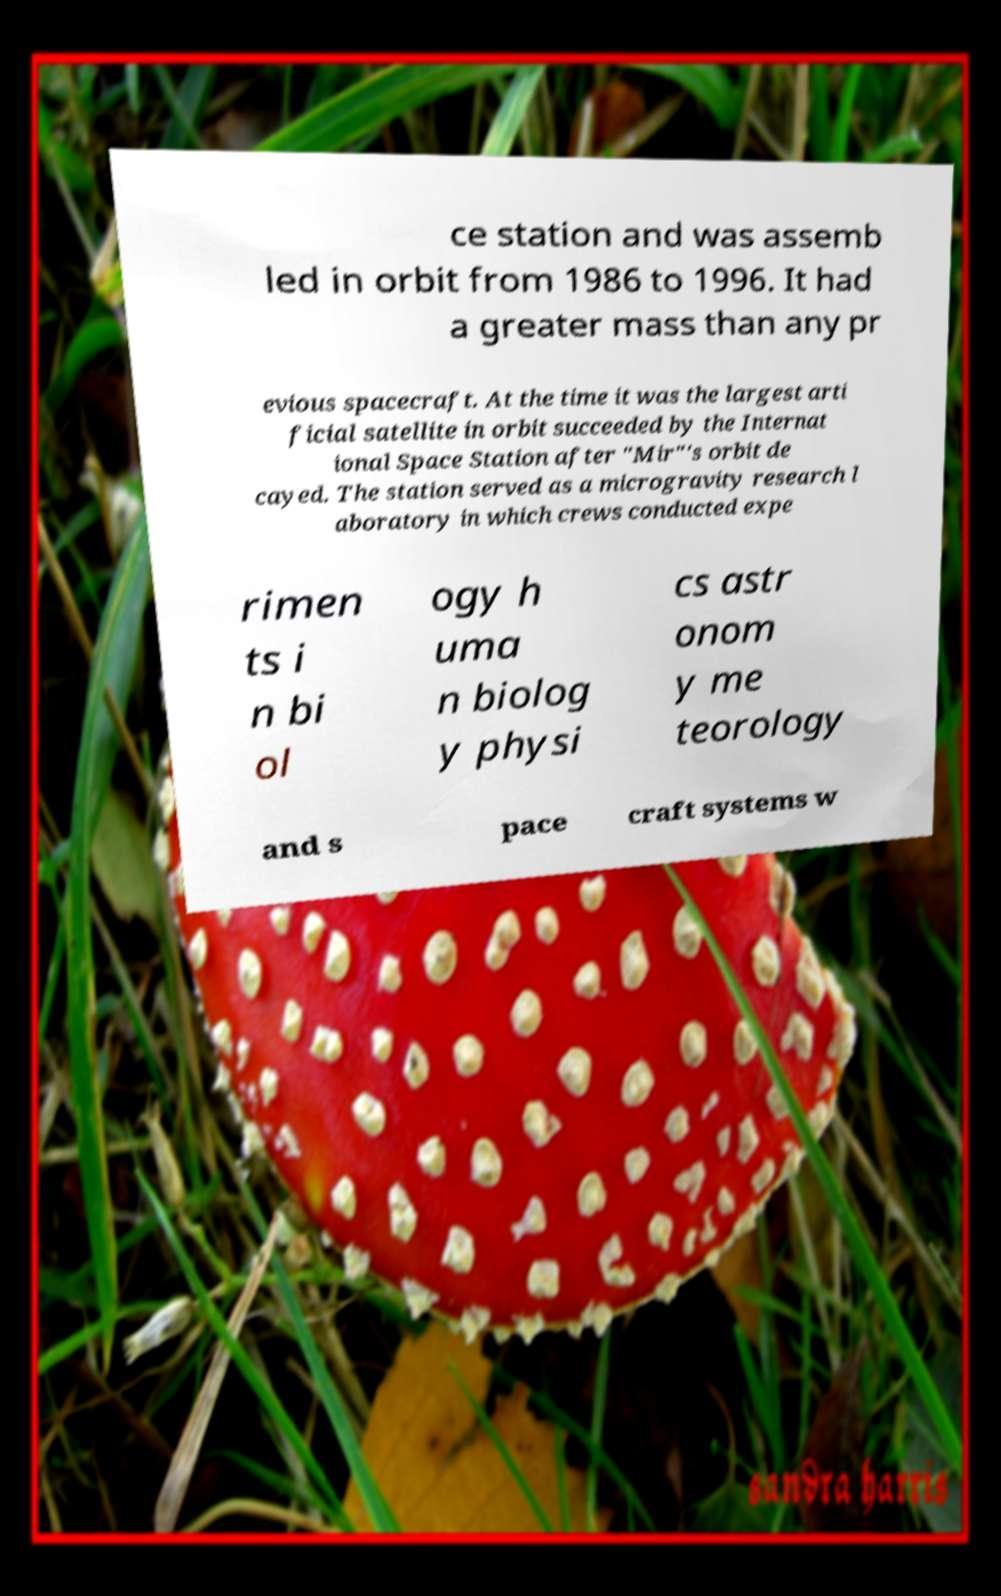Can you accurately transcribe the text from the provided image for me? ce station and was assemb led in orbit from 1986 to 1996. It had a greater mass than any pr evious spacecraft. At the time it was the largest arti ficial satellite in orbit succeeded by the Internat ional Space Station after "Mir"'s orbit de cayed. The station served as a microgravity research l aboratory in which crews conducted expe rimen ts i n bi ol ogy h uma n biolog y physi cs astr onom y me teorology and s pace craft systems w 